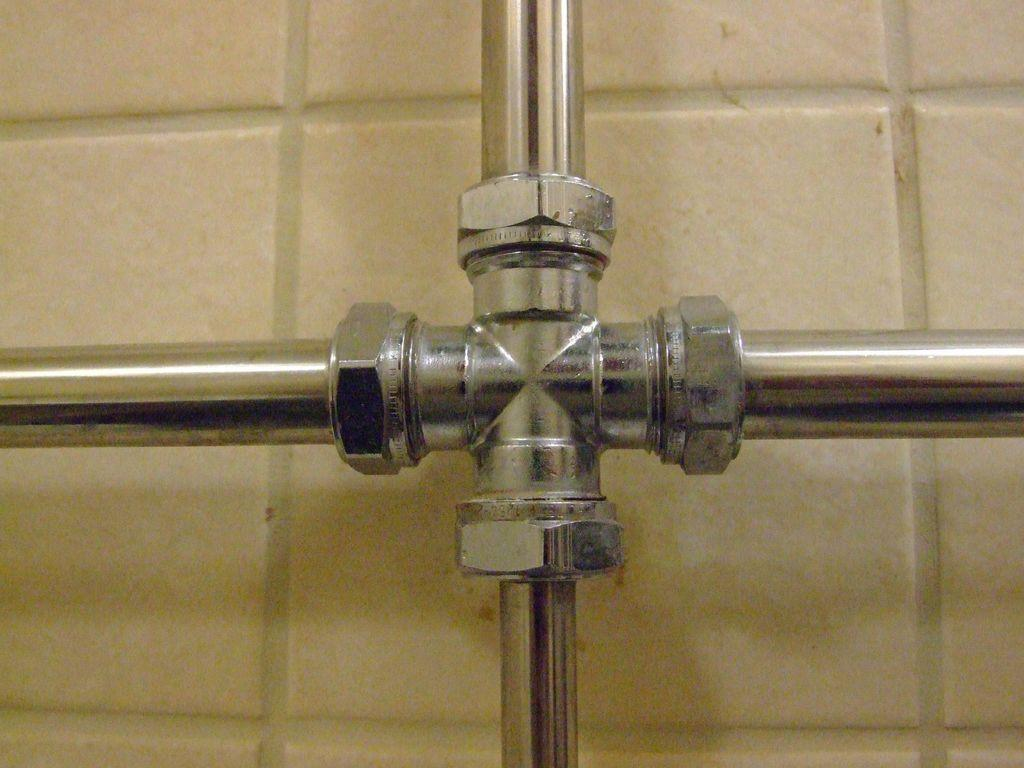What type of object is located in the center of the image? There is a metal object in the center of the image. What type of scarecrow can be seen playing a musical instrument in the image? There is no scarecrow or musical instrument present in the image. What type of wind can be seen blowing through the image? There is no wind visible in the image. 